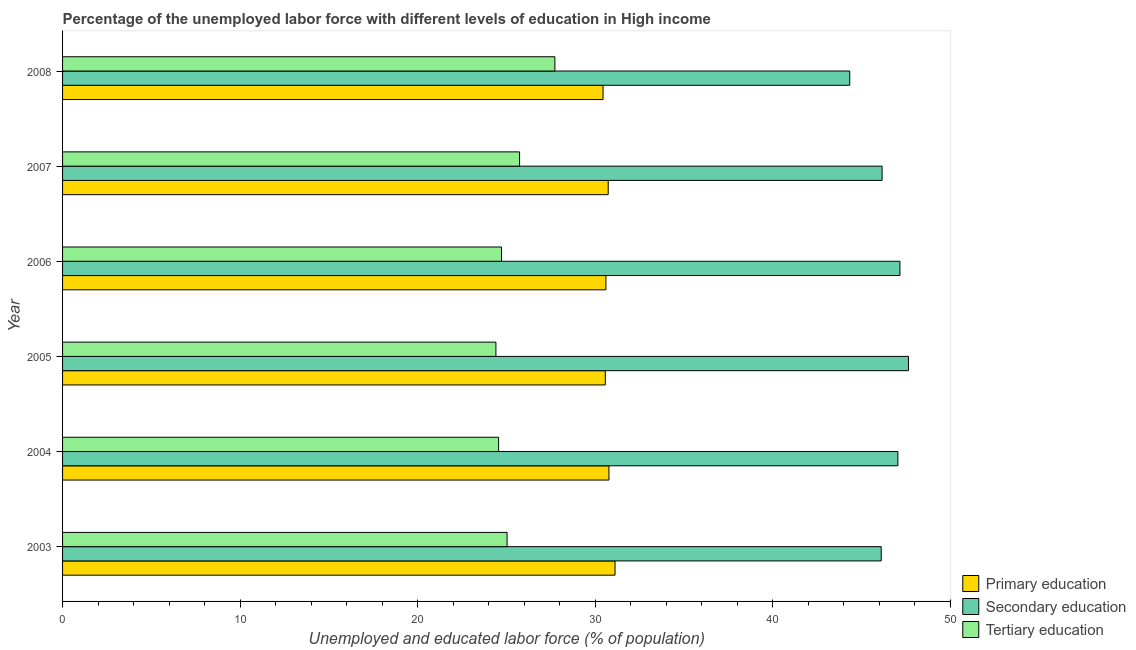How many different coloured bars are there?
Ensure brevity in your answer.  3. How many bars are there on the 2nd tick from the top?
Provide a succinct answer. 3. How many bars are there on the 2nd tick from the bottom?
Your answer should be very brief. 3. What is the label of the 1st group of bars from the top?
Ensure brevity in your answer.  2008. In how many cases, is the number of bars for a given year not equal to the number of legend labels?
Give a very brief answer. 0. What is the percentage of labor force who received tertiary education in 2007?
Offer a very short reply. 25.74. Across all years, what is the maximum percentage of labor force who received primary education?
Your answer should be very brief. 31.12. Across all years, what is the minimum percentage of labor force who received secondary education?
Your answer should be very brief. 44.33. In which year was the percentage of labor force who received primary education maximum?
Offer a very short reply. 2003. In which year was the percentage of labor force who received secondary education minimum?
Your response must be concise. 2008. What is the total percentage of labor force who received tertiary education in the graph?
Your response must be concise. 152.19. What is the difference between the percentage of labor force who received primary education in 2003 and that in 2007?
Provide a succinct answer. 0.39. What is the difference between the percentage of labor force who received secondary education in 2007 and the percentage of labor force who received primary education in 2005?
Keep it short and to the point. 15.59. What is the average percentage of labor force who received tertiary education per year?
Offer a terse response. 25.36. In the year 2007, what is the difference between the percentage of labor force who received secondary education and percentage of labor force who received primary education?
Keep it short and to the point. 15.43. What is the ratio of the percentage of labor force who received tertiary education in 2003 to that in 2005?
Offer a very short reply. 1.03. What is the difference between the highest and the second highest percentage of labor force who received primary education?
Make the answer very short. 0.34. What is the difference between the highest and the lowest percentage of labor force who received secondary education?
Offer a very short reply. 3.31. Is the sum of the percentage of labor force who received primary education in 2003 and 2007 greater than the maximum percentage of labor force who received secondary education across all years?
Keep it short and to the point. Yes. What does the 2nd bar from the bottom in 2008 represents?
Keep it short and to the point. Secondary education. Is it the case that in every year, the sum of the percentage of labor force who received primary education and percentage of labor force who received secondary education is greater than the percentage of labor force who received tertiary education?
Offer a terse response. Yes. How many bars are there?
Offer a terse response. 18. Are all the bars in the graph horizontal?
Keep it short and to the point. Yes. What is the difference between two consecutive major ticks on the X-axis?
Your answer should be compact. 10. Does the graph contain grids?
Offer a terse response. No. How many legend labels are there?
Offer a very short reply. 3. How are the legend labels stacked?
Make the answer very short. Vertical. What is the title of the graph?
Keep it short and to the point. Percentage of the unemployed labor force with different levels of education in High income. What is the label or title of the X-axis?
Your answer should be very brief. Unemployed and educated labor force (% of population). What is the label or title of the Y-axis?
Keep it short and to the point. Year. What is the Unemployed and educated labor force (% of population) of Primary education in 2003?
Your response must be concise. 31.12. What is the Unemployed and educated labor force (% of population) in Secondary education in 2003?
Your response must be concise. 46.11. What is the Unemployed and educated labor force (% of population) in Tertiary education in 2003?
Your answer should be very brief. 25.04. What is the Unemployed and educated labor force (% of population) in Primary education in 2004?
Offer a terse response. 30.77. What is the Unemployed and educated labor force (% of population) of Secondary education in 2004?
Ensure brevity in your answer.  47.05. What is the Unemployed and educated labor force (% of population) of Tertiary education in 2004?
Provide a short and direct response. 24.56. What is the Unemployed and educated labor force (% of population) in Primary education in 2005?
Offer a very short reply. 30.57. What is the Unemployed and educated labor force (% of population) of Secondary education in 2005?
Make the answer very short. 47.64. What is the Unemployed and educated labor force (% of population) of Tertiary education in 2005?
Provide a short and direct response. 24.41. What is the Unemployed and educated labor force (% of population) in Primary education in 2006?
Offer a very short reply. 30.6. What is the Unemployed and educated labor force (% of population) in Secondary education in 2006?
Your response must be concise. 47.16. What is the Unemployed and educated labor force (% of population) in Tertiary education in 2006?
Your answer should be very brief. 24.72. What is the Unemployed and educated labor force (% of population) of Primary education in 2007?
Provide a short and direct response. 30.73. What is the Unemployed and educated labor force (% of population) of Secondary education in 2007?
Your answer should be compact. 46.16. What is the Unemployed and educated labor force (% of population) in Tertiary education in 2007?
Your answer should be compact. 25.74. What is the Unemployed and educated labor force (% of population) of Primary education in 2008?
Offer a very short reply. 30.44. What is the Unemployed and educated labor force (% of population) of Secondary education in 2008?
Your response must be concise. 44.33. What is the Unemployed and educated labor force (% of population) in Tertiary education in 2008?
Your answer should be compact. 27.73. Across all years, what is the maximum Unemployed and educated labor force (% of population) of Primary education?
Make the answer very short. 31.12. Across all years, what is the maximum Unemployed and educated labor force (% of population) of Secondary education?
Offer a terse response. 47.64. Across all years, what is the maximum Unemployed and educated labor force (% of population) of Tertiary education?
Offer a terse response. 27.73. Across all years, what is the minimum Unemployed and educated labor force (% of population) of Primary education?
Offer a very short reply. 30.44. Across all years, what is the minimum Unemployed and educated labor force (% of population) of Secondary education?
Your answer should be compact. 44.33. Across all years, what is the minimum Unemployed and educated labor force (% of population) of Tertiary education?
Make the answer very short. 24.41. What is the total Unemployed and educated labor force (% of population) of Primary education in the graph?
Offer a terse response. 184.23. What is the total Unemployed and educated labor force (% of population) of Secondary education in the graph?
Provide a succinct answer. 278.45. What is the total Unemployed and educated labor force (% of population) in Tertiary education in the graph?
Provide a succinct answer. 152.19. What is the difference between the Unemployed and educated labor force (% of population) in Primary education in 2003 and that in 2004?
Ensure brevity in your answer.  0.34. What is the difference between the Unemployed and educated labor force (% of population) in Secondary education in 2003 and that in 2004?
Your answer should be compact. -0.94. What is the difference between the Unemployed and educated labor force (% of population) of Tertiary education in 2003 and that in 2004?
Your response must be concise. 0.48. What is the difference between the Unemployed and educated labor force (% of population) of Primary education in 2003 and that in 2005?
Your answer should be very brief. 0.55. What is the difference between the Unemployed and educated labor force (% of population) in Secondary education in 2003 and that in 2005?
Your answer should be compact. -1.53. What is the difference between the Unemployed and educated labor force (% of population) of Tertiary education in 2003 and that in 2005?
Make the answer very short. 0.63. What is the difference between the Unemployed and educated labor force (% of population) of Primary education in 2003 and that in 2006?
Your answer should be very brief. 0.51. What is the difference between the Unemployed and educated labor force (% of population) of Secondary education in 2003 and that in 2006?
Your answer should be very brief. -1.05. What is the difference between the Unemployed and educated labor force (% of population) of Tertiary education in 2003 and that in 2006?
Your answer should be compact. 0.31. What is the difference between the Unemployed and educated labor force (% of population) in Primary education in 2003 and that in 2007?
Ensure brevity in your answer.  0.38. What is the difference between the Unemployed and educated labor force (% of population) of Secondary education in 2003 and that in 2007?
Your response must be concise. -0.05. What is the difference between the Unemployed and educated labor force (% of population) of Tertiary education in 2003 and that in 2007?
Your answer should be compact. -0.7. What is the difference between the Unemployed and educated labor force (% of population) in Primary education in 2003 and that in 2008?
Offer a terse response. 0.67. What is the difference between the Unemployed and educated labor force (% of population) in Secondary education in 2003 and that in 2008?
Your answer should be very brief. 1.77. What is the difference between the Unemployed and educated labor force (% of population) of Tertiary education in 2003 and that in 2008?
Ensure brevity in your answer.  -2.69. What is the difference between the Unemployed and educated labor force (% of population) of Primary education in 2004 and that in 2005?
Offer a very short reply. 0.2. What is the difference between the Unemployed and educated labor force (% of population) of Secondary education in 2004 and that in 2005?
Offer a very short reply. -0.6. What is the difference between the Unemployed and educated labor force (% of population) of Tertiary education in 2004 and that in 2005?
Make the answer very short. 0.15. What is the difference between the Unemployed and educated labor force (% of population) in Primary education in 2004 and that in 2006?
Your answer should be compact. 0.17. What is the difference between the Unemployed and educated labor force (% of population) in Secondary education in 2004 and that in 2006?
Keep it short and to the point. -0.12. What is the difference between the Unemployed and educated labor force (% of population) of Tertiary education in 2004 and that in 2006?
Keep it short and to the point. -0.16. What is the difference between the Unemployed and educated labor force (% of population) in Primary education in 2004 and that in 2007?
Offer a terse response. 0.04. What is the difference between the Unemployed and educated labor force (% of population) in Secondary education in 2004 and that in 2007?
Provide a short and direct response. 0.89. What is the difference between the Unemployed and educated labor force (% of population) of Tertiary education in 2004 and that in 2007?
Offer a very short reply. -1.18. What is the difference between the Unemployed and educated labor force (% of population) in Primary education in 2004 and that in 2008?
Your response must be concise. 0.33. What is the difference between the Unemployed and educated labor force (% of population) in Secondary education in 2004 and that in 2008?
Keep it short and to the point. 2.71. What is the difference between the Unemployed and educated labor force (% of population) of Tertiary education in 2004 and that in 2008?
Your answer should be very brief. -3.17. What is the difference between the Unemployed and educated labor force (% of population) in Primary education in 2005 and that in 2006?
Offer a very short reply. -0.03. What is the difference between the Unemployed and educated labor force (% of population) in Secondary education in 2005 and that in 2006?
Provide a short and direct response. 0.48. What is the difference between the Unemployed and educated labor force (% of population) in Tertiary education in 2005 and that in 2006?
Your response must be concise. -0.31. What is the difference between the Unemployed and educated labor force (% of population) of Primary education in 2005 and that in 2007?
Your answer should be very brief. -0.16. What is the difference between the Unemployed and educated labor force (% of population) of Secondary education in 2005 and that in 2007?
Give a very brief answer. 1.48. What is the difference between the Unemployed and educated labor force (% of population) of Tertiary education in 2005 and that in 2007?
Keep it short and to the point. -1.33. What is the difference between the Unemployed and educated labor force (% of population) in Primary education in 2005 and that in 2008?
Your answer should be compact. 0.13. What is the difference between the Unemployed and educated labor force (% of population) of Secondary education in 2005 and that in 2008?
Your response must be concise. 3.31. What is the difference between the Unemployed and educated labor force (% of population) in Tertiary education in 2005 and that in 2008?
Provide a short and direct response. -3.32. What is the difference between the Unemployed and educated labor force (% of population) in Primary education in 2006 and that in 2007?
Your answer should be very brief. -0.13. What is the difference between the Unemployed and educated labor force (% of population) in Tertiary education in 2006 and that in 2007?
Your answer should be compact. -1.02. What is the difference between the Unemployed and educated labor force (% of population) in Primary education in 2006 and that in 2008?
Offer a terse response. 0.16. What is the difference between the Unemployed and educated labor force (% of population) of Secondary education in 2006 and that in 2008?
Give a very brief answer. 2.83. What is the difference between the Unemployed and educated labor force (% of population) in Tertiary education in 2006 and that in 2008?
Offer a very short reply. -3.01. What is the difference between the Unemployed and educated labor force (% of population) of Primary education in 2007 and that in 2008?
Provide a short and direct response. 0.29. What is the difference between the Unemployed and educated labor force (% of population) in Secondary education in 2007 and that in 2008?
Provide a short and direct response. 1.82. What is the difference between the Unemployed and educated labor force (% of population) of Tertiary education in 2007 and that in 2008?
Ensure brevity in your answer.  -1.99. What is the difference between the Unemployed and educated labor force (% of population) of Primary education in 2003 and the Unemployed and educated labor force (% of population) of Secondary education in 2004?
Ensure brevity in your answer.  -15.93. What is the difference between the Unemployed and educated labor force (% of population) in Primary education in 2003 and the Unemployed and educated labor force (% of population) in Tertiary education in 2004?
Keep it short and to the point. 6.56. What is the difference between the Unemployed and educated labor force (% of population) in Secondary education in 2003 and the Unemployed and educated labor force (% of population) in Tertiary education in 2004?
Offer a terse response. 21.55. What is the difference between the Unemployed and educated labor force (% of population) of Primary education in 2003 and the Unemployed and educated labor force (% of population) of Secondary education in 2005?
Keep it short and to the point. -16.53. What is the difference between the Unemployed and educated labor force (% of population) in Primary education in 2003 and the Unemployed and educated labor force (% of population) in Tertiary education in 2005?
Your answer should be very brief. 6.71. What is the difference between the Unemployed and educated labor force (% of population) of Secondary education in 2003 and the Unemployed and educated labor force (% of population) of Tertiary education in 2005?
Offer a terse response. 21.7. What is the difference between the Unemployed and educated labor force (% of population) in Primary education in 2003 and the Unemployed and educated labor force (% of population) in Secondary education in 2006?
Your response must be concise. -16.05. What is the difference between the Unemployed and educated labor force (% of population) in Primary education in 2003 and the Unemployed and educated labor force (% of population) in Tertiary education in 2006?
Your response must be concise. 6.4. What is the difference between the Unemployed and educated labor force (% of population) in Secondary education in 2003 and the Unemployed and educated labor force (% of population) in Tertiary education in 2006?
Your answer should be compact. 21.39. What is the difference between the Unemployed and educated labor force (% of population) of Primary education in 2003 and the Unemployed and educated labor force (% of population) of Secondary education in 2007?
Give a very brief answer. -15.04. What is the difference between the Unemployed and educated labor force (% of population) of Primary education in 2003 and the Unemployed and educated labor force (% of population) of Tertiary education in 2007?
Offer a terse response. 5.38. What is the difference between the Unemployed and educated labor force (% of population) in Secondary education in 2003 and the Unemployed and educated labor force (% of population) in Tertiary education in 2007?
Your answer should be compact. 20.37. What is the difference between the Unemployed and educated labor force (% of population) of Primary education in 2003 and the Unemployed and educated labor force (% of population) of Secondary education in 2008?
Your answer should be very brief. -13.22. What is the difference between the Unemployed and educated labor force (% of population) of Primary education in 2003 and the Unemployed and educated labor force (% of population) of Tertiary education in 2008?
Offer a very short reply. 3.39. What is the difference between the Unemployed and educated labor force (% of population) of Secondary education in 2003 and the Unemployed and educated labor force (% of population) of Tertiary education in 2008?
Offer a terse response. 18.38. What is the difference between the Unemployed and educated labor force (% of population) in Primary education in 2004 and the Unemployed and educated labor force (% of population) in Secondary education in 2005?
Provide a succinct answer. -16.87. What is the difference between the Unemployed and educated labor force (% of population) in Primary education in 2004 and the Unemployed and educated labor force (% of population) in Tertiary education in 2005?
Ensure brevity in your answer.  6.36. What is the difference between the Unemployed and educated labor force (% of population) in Secondary education in 2004 and the Unemployed and educated labor force (% of population) in Tertiary education in 2005?
Offer a very short reply. 22.64. What is the difference between the Unemployed and educated labor force (% of population) in Primary education in 2004 and the Unemployed and educated labor force (% of population) in Secondary education in 2006?
Give a very brief answer. -16.39. What is the difference between the Unemployed and educated labor force (% of population) in Primary education in 2004 and the Unemployed and educated labor force (% of population) in Tertiary education in 2006?
Provide a succinct answer. 6.05. What is the difference between the Unemployed and educated labor force (% of population) of Secondary education in 2004 and the Unemployed and educated labor force (% of population) of Tertiary education in 2006?
Provide a short and direct response. 22.32. What is the difference between the Unemployed and educated labor force (% of population) in Primary education in 2004 and the Unemployed and educated labor force (% of population) in Secondary education in 2007?
Offer a very short reply. -15.38. What is the difference between the Unemployed and educated labor force (% of population) of Primary education in 2004 and the Unemployed and educated labor force (% of population) of Tertiary education in 2007?
Provide a succinct answer. 5.03. What is the difference between the Unemployed and educated labor force (% of population) of Secondary education in 2004 and the Unemployed and educated labor force (% of population) of Tertiary education in 2007?
Provide a short and direct response. 21.31. What is the difference between the Unemployed and educated labor force (% of population) of Primary education in 2004 and the Unemployed and educated labor force (% of population) of Secondary education in 2008?
Ensure brevity in your answer.  -13.56. What is the difference between the Unemployed and educated labor force (% of population) in Primary education in 2004 and the Unemployed and educated labor force (% of population) in Tertiary education in 2008?
Offer a very short reply. 3.04. What is the difference between the Unemployed and educated labor force (% of population) of Secondary education in 2004 and the Unemployed and educated labor force (% of population) of Tertiary education in 2008?
Make the answer very short. 19.32. What is the difference between the Unemployed and educated labor force (% of population) in Primary education in 2005 and the Unemployed and educated labor force (% of population) in Secondary education in 2006?
Offer a very short reply. -16.59. What is the difference between the Unemployed and educated labor force (% of population) of Primary education in 2005 and the Unemployed and educated labor force (% of population) of Tertiary education in 2006?
Make the answer very short. 5.85. What is the difference between the Unemployed and educated labor force (% of population) of Secondary education in 2005 and the Unemployed and educated labor force (% of population) of Tertiary education in 2006?
Give a very brief answer. 22.92. What is the difference between the Unemployed and educated labor force (% of population) in Primary education in 2005 and the Unemployed and educated labor force (% of population) in Secondary education in 2007?
Offer a very short reply. -15.59. What is the difference between the Unemployed and educated labor force (% of population) in Primary education in 2005 and the Unemployed and educated labor force (% of population) in Tertiary education in 2007?
Your answer should be compact. 4.83. What is the difference between the Unemployed and educated labor force (% of population) of Secondary education in 2005 and the Unemployed and educated labor force (% of population) of Tertiary education in 2007?
Your answer should be very brief. 21.9. What is the difference between the Unemployed and educated labor force (% of population) in Primary education in 2005 and the Unemployed and educated labor force (% of population) in Secondary education in 2008?
Make the answer very short. -13.77. What is the difference between the Unemployed and educated labor force (% of population) in Primary education in 2005 and the Unemployed and educated labor force (% of population) in Tertiary education in 2008?
Give a very brief answer. 2.84. What is the difference between the Unemployed and educated labor force (% of population) of Secondary education in 2005 and the Unemployed and educated labor force (% of population) of Tertiary education in 2008?
Make the answer very short. 19.91. What is the difference between the Unemployed and educated labor force (% of population) of Primary education in 2006 and the Unemployed and educated labor force (% of population) of Secondary education in 2007?
Offer a terse response. -15.55. What is the difference between the Unemployed and educated labor force (% of population) in Primary education in 2006 and the Unemployed and educated labor force (% of population) in Tertiary education in 2007?
Your response must be concise. 4.86. What is the difference between the Unemployed and educated labor force (% of population) of Secondary education in 2006 and the Unemployed and educated labor force (% of population) of Tertiary education in 2007?
Provide a short and direct response. 21.42. What is the difference between the Unemployed and educated labor force (% of population) in Primary education in 2006 and the Unemployed and educated labor force (% of population) in Secondary education in 2008?
Provide a succinct answer. -13.73. What is the difference between the Unemployed and educated labor force (% of population) of Primary education in 2006 and the Unemployed and educated labor force (% of population) of Tertiary education in 2008?
Keep it short and to the point. 2.87. What is the difference between the Unemployed and educated labor force (% of population) of Secondary education in 2006 and the Unemployed and educated labor force (% of population) of Tertiary education in 2008?
Your response must be concise. 19.43. What is the difference between the Unemployed and educated labor force (% of population) of Primary education in 2007 and the Unemployed and educated labor force (% of population) of Secondary education in 2008?
Ensure brevity in your answer.  -13.6. What is the difference between the Unemployed and educated labor force (% of population) of Primary education in 2007 and the Unemployed and educated labor force (% of population) of Tertiary education in 2008?
Offer a very short reply. 3. What is the difference between the Unemployed and educated labor force (% of population) of Secondary education in 2007 and the Unemployed and educated labor force (% of population) of Tertiary education in 2008?
Offer a terse response. 18.43. What is the average Unemployed and educated labor force (% of population) of Primary education per year?
Ensure brevity in your answer.  30.71. What is the average Unemployed and educated labor force (% of population) of Secondary education per year?
Provide a succinct answer. 46.41. What is the average Unemployed and educated labor force (% of population) in Tertiary education per year?
Offer a very short reply. 25.36. In the year 2003, what is the difference between the Unemployed and educated labor force (% of population) in Primary education and Unemployed and educated labor force (% of population) in Secondary education?
Your answer should be very brief. -14.99. In the year 2003, what is the difference between the Unemployed and educated labor force (% of population) of Primary education and Unemployed and educated labor force (% of population) of Tertiary education?
Provide a short and direct response. 6.08. In the year 2003, what is the difference between the Unemployed and educated labor force (% of population) in Secondary education and Unemployed and educated labor force (% of population) in Tertiary education?
Make the answer very short. 21.07. In the year 2004, what is the difference between the Unemployed and educated labor force (% of population) of Primary education and Unemployed and educated labor force (% of population) of Secondary education?
Offer a very short reply. -16.27. In the year 2004, what is the difference between the Unemployed and educated labor force (% of population) in Primary education and Unemployed and educated labor force (% of population) in Tertiary education?
Give a very brief answer. 6.21. In the year 2004, what is the difference between the Unemployed and educated labor force (% of population) in Secondary education and Unemployed and educated labor force (% of population) in Tertiary education?
Give a very brief answer. 22.49. In the year 2005, what is the difference between the Unemployed and educated labor force (% of population) of Primary education and Unemployed and educated labor force (% of population) of Secondary education?
Give a very brief answer. -17.07. In the year 2005, what is the difference between the Unemployed and educated labor force (% of population) in Primary education and Unemployed and educated labor force (% of population) in Tertiary education?
Offer a terse response. 6.16. In the year 2005, what is the difference between the Unemployed and educated labor force (% of population) in Secondary education and Unemployed and educated labor force (% of population) in Tertiary education?
Give a very brief answer. 23.23. In the year 2006, what is the difference between the Unemployed and educated labor force (% of population) of Primary education and Unemployed and educated labor force (% of population) of Secondary education?
Give a very brief answer. -16.56. In the year 2006, what is the difference between the Unemployed and educated labor force (% of population) in Primary education and Unemployed and educated labor force (% of population) in Tertiary education?
Provide a succinct answer. 5.88. In the year 2006, what is the difference between the Unemployed and educated labor force (% of population) of Secondary education and Unemployed and educated labor force (% of population) of Tertiary education?
Your response must be concise. 22.44. In the year 2007, what is the difference between the Unemployed and educated labor force (% of population) of Primary education and Unemployed and educated labor force (% of population) of Secondary education?
Provide a short and direct response. -15.43. In the year 2007, what is the difference between the Unemployed and educated labor force (% of population) in Primary education and Unemployed and educated labor force (% of population) in Tertiary education?
Your answer should be compact. 4.99. In the year 2007, what is the difference between the Unemployed and educated labor force (% of population) of Secondary education and Unemployed and educated labor force (% of population) of Tertiary education?
Make the answer very short. 20.42. In the year 2008, what is the difference between the Unemployed and educated labor force (% of population) of Primary education and Unemployed and educated labor force (% of population) of Secondary education?
Make the answer very short. -13.89. In the year 2008, what is the difference between the Unemployed and educated labor force (% of population) in Primary education and Unemployed and educated labor force (% of population) in Tertiary education?
Ensure brevity in your answer.  2.71. In the year 2008, what is the difference between the Unemployed and educated labor force (% of population) of Secondary education and Unemployed and educated labor force (% of population) of Tertiary education?
Your answer should be compact. 16.61. What is the ratio of the Unemployed and educated labor force (% of population) in Primary education in 2003 to that in 2004?
Ensure brevity in your answer.  1.01. What is the ratio of the Unemployed and educated labor force (% of population) in Secondary education in 2003 to that in 2004?
Your response must be concise. 0.98. What is the ratio of the Unemployed and educated labor force (% of population) in Tertiary education in 2003 to that in 2004?
Make the answer very short. 1.02. What is the ratio of the Unemployed and educated labor force (% of population) of Primary education in 2003 to that in 2005?
Keep it short and to the point. 1.02. What is the ratio of the Unemployed and educated labor force (% of population) in Secondary education in 2003 to that in 2005?
Your answer should be compact. 0.97. What is the ratio of the Unemployed and educated labor force (% of population) of Tertiary education in 2003 to that in 2005?
Ensure brevity in your answer.  1.03. What is the ratio of the Unemployed and educated labor force (% of population) of Primary education in 2003 to that in 2006?
Provide a succinct answer. 1.02. What is the ratio of the Unemployed and educated labor force (% of population) in Secondary education in 2003 to that in 2006?
Your answer should be very brief. 0.98. What is the ratio of the Unemployed and educated labor force (% of population) of Tertiary education in 2003 to that in 2006?
Keep it short and to the point. 1.01. What is the ratio of the Unemployed and educated labor force (% of population) in Primary education in 2003 to that in 2007?
Your response must be concise. 1.01. What is the ratio of the Unemployed and educated labor force (% of population) in Secondary education in 2003 to that in 2007?
Give a very brief answer. 1. What is the ratio of the Unemployed and educated labor force (% of population) in Tertiary education in 2003 to that in 2007?
Provide a short and direct response. 0.97. What is the ratio of the Unemployed and educated labor force (% of population) in Primary education in 2003 to that in 2008?
Your answer should be very brief. 1.02. What is the ratio of the Unemployed and educated labor force (% of population) in Secondary education in 2003 to that in 2008?
Offer a terse response. 1.04. What is the ratio of the Unemployed and educated labor force (% of population) in Tertiary education in 2003 to that in 2008?
Offer a very short reply. 0.9. What is the ratio of the Unemployed and educated labor force (% of population) in Secondary education in 2004 to that in 2005?
Provide a short and direct response. 0.99. What is the ratio of the Unemployed and educated labor force (% of population) of Tertiary education in 2004 to that in 2005?
Provide a short and direct response. 1.01. What is the ratio of the Unemployed and educated labor force (% of population) in Primary education in 2004 to that in 2006?
Ensure brevity in your answer.  1.01. What is the ratio of the Unemployed and educated labor force (% of population) of Secondary education in 2004 to that in 2006?
Give a very brief answer. 1. What is the ratio of the Unemployed and educated labor force (% of population) of Tertiary education in 2004 to that in 2006?
Your answer should be very brief. 0.99. What is the ratio of the Unemployed and educated labor force (% of population) in Secondary education in 2004 to that in 2007?
Keep it short and to the point. 1.02. What is the ratio of the Unemployed and educated labor force (% of population) of Tertiary education in 2004 to that in 2007?
Your answer should be compact. 0.95. What is the ratio of the Unemployed and educated labor force (% of population) in Primary education in 2004 to that in 2008?
Your answer should be compact. 1.01. What is the ratio of the Unemployed and educated labor force (% of population) of Secondary education in 2004 to that in 2008?
Provide a succinct answer. 1.06. What is the ratio of the Unemployed and educated labor force (% of population) of Tertiary education in 2004 to that in 2008?
Provide a short and direct response. 0.89. What is the ratio of the Unemployed and educated labor force (% of population) in Primary education in 2005 to that in 2006?
Provide a short and direct response. 1. What is the ratio of the Unemployed and educated labor force (% of population) of Secondary education in 2005 to that in 2006?
Offer a very short reply. 1.01. What is the ratio of the Unemployed and educated labor force (% of population) in Tertiary education in 2005 to that in 2006?
Provide a succinct answer. 0.99. What is the ratio of the Unemployed and educated labor force (% of population) of Primary education in 2005 to that in 2007?
Give a very brief answer. 0.99. What is the ratio of the Unemployed and educated labor force (% of population) of Secondary education in 2005 to that in 2007?
Your response must be concise. 1.03. What is the ratio of the Unemployed and educated labor force (% of population) of Tertiary education in 2005 to that in 2007?
Offer a very short reply. 0.95. What is the ratio of the Unemployed and educated labor force (% of population) of Secondary education in 2005 to that in 2008?
Make the answer very short. 1.07. What is the ratio of the Unemployed and educated labor force (% of population) of Tertiary education in 2005 to that in 2008?
Provide a succinct answer. 0.88. What is the ratio of the Unemployed and educated labor force (% of population) of Secondary education in 2006 to that in 2007?
Keep it short and to the point. 1.02. What is the ratio of the Unemployed and educated labor force (% of population) of Tertiary education in 2006 to that in 2007?
Ensure brevity in your answer.  0.96. What is the ratio of the Unemployed and educated labor force (% of population) in Primary education in 2006 to that in 2008?
Provide a succinct answer. 1.01. What is the ratio of the Unemployed and educated labor force (% of population) of Secondary education in 2006 to that in 2008?
Make the answer very short. 1.06. What is the ratio of the Unemployed and educated labor force (% of population) in Tertiary education in 2006 to that in 2008?
Offer a very short reply. 0.89. What is the ratio of the Unemployed and educated labor force (% of population) of Primary education in 2007 to that in 2008?
Provide a short and direct response. 1.01. What is the ratio of the Unemployed and educated labor force (% of population) in Secondary education in 2007 to that in 2008?
Offer a terse response. 1.04. What is the ratio of the Unemployed and educated labor force (% of population) of Tertiary education in 2007 to that in 2008?
Provide a succinct answer. 0.93. What is the difference between the highest and the second highest Unemployed and educated labor force (% of population) of Primary education?
Make the answer very short. 0.34. What is the difference between the highest and the second highest Unemployed and educated labor force (% of population) in Secondary education?
Offer a very short reply. 0.48. What is the difference between the highest and the second highest Unemployed and educated labor force (% of population) of Tertiary education?
Your answer should be compact. 1.99. What is the difference between the highest and the lowest Unemployed and educated labor force (% of population) of Primary education?
Keep it short and to the point. 0.67. What is the difference between the highest and the lowest Unemployed and educated labor force (% of population) of Secondary education?
Your answer should be compact. 3.31. What is the difference between the highest and the lowest Unemployed and educated labor force (% of population) of Tertiary education?
Offer a very short reply. 3.32. 